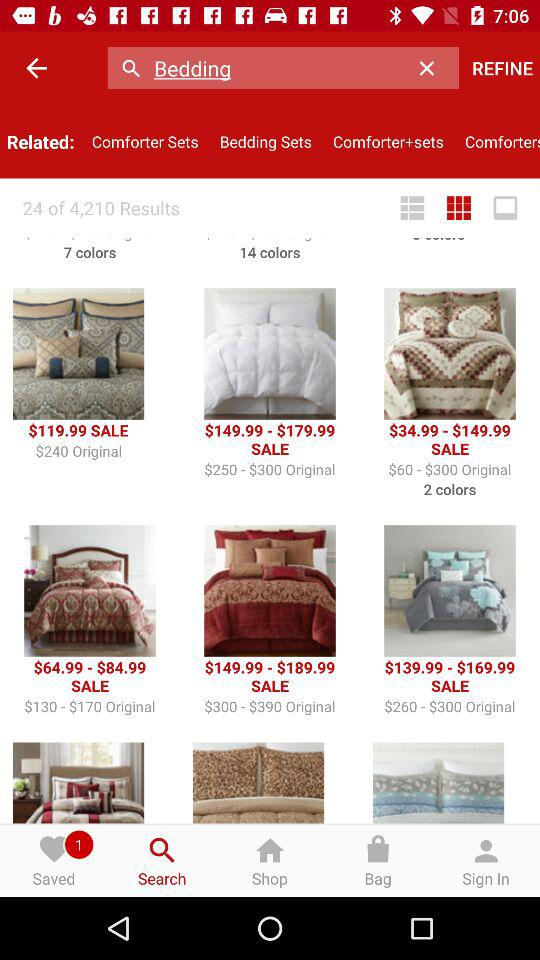Which option is selected in the bottom bar? The selected option in the bottom bar is "Search". 